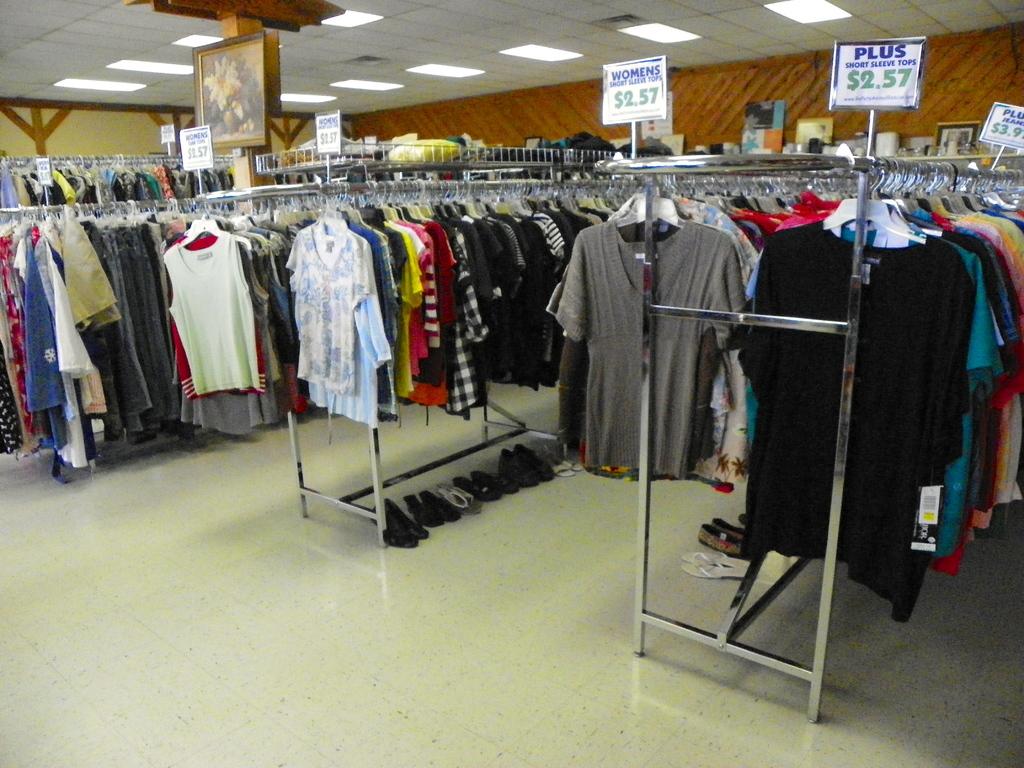How much are the shirts on the right side worth?
Your answer should be very brief. $2.57. What´s the cheapest shirt you have?
Your response must be concise. 2.57. 